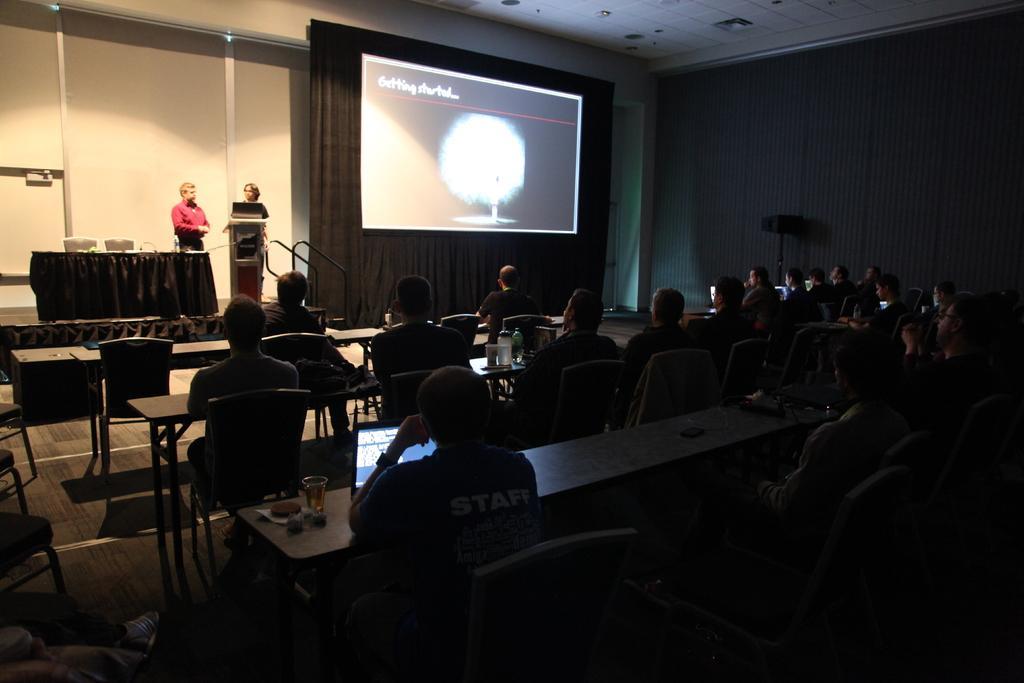Could you give a brief overview of what you see in this image? This is the picture of a room. In this image there are group of people sitting on the chairs. There are tables and chairs and there are devices, bottles and glasses on the table. On the left side of the image there are two persons standing on the stage and there is a table and there are chairs and there is a podium on the stage. At the back there is a screen and curtain. At the top there are lights. 